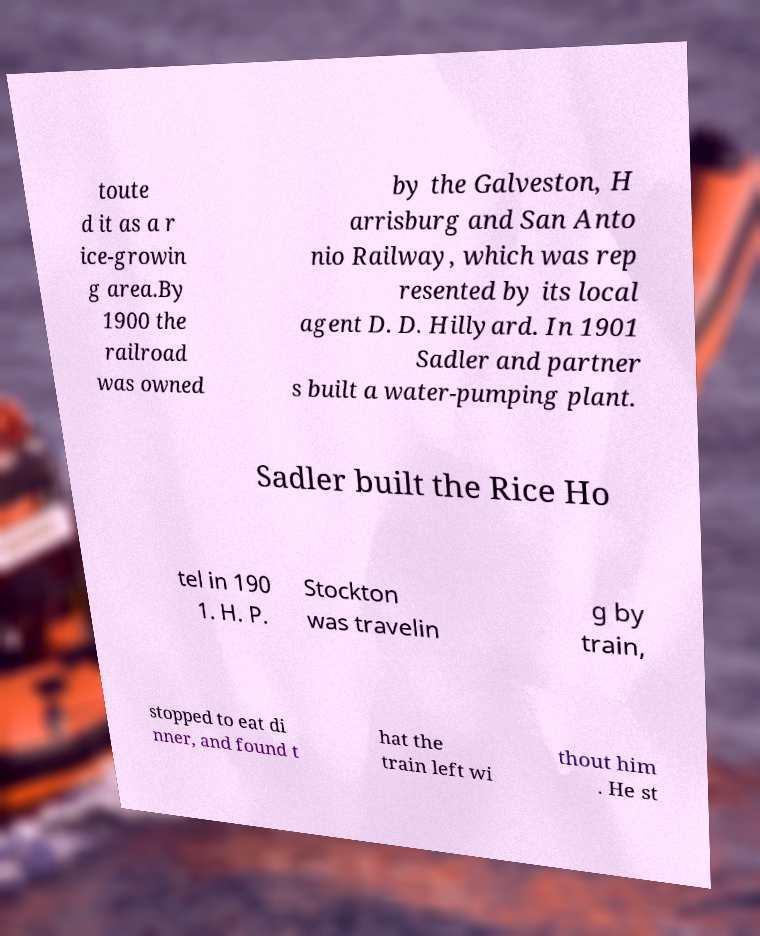What messages or text are displayed in this image? I need them in a readable, typed format. toute d it as a r ice-growin g area.By 1900 the railroad was owned by the Galveston, H arrisburg and San Anto nio Railway, which was rep resented by its local agent D. D. Hillyard. In 1901 Sadler and partner s built a water-pumping plant. Sadler built the Rice Ho tel in 190 1. H. P. Stockton was travelin g by train, stopped to eat di nner, and found t hat the train left wi thout him . He st 